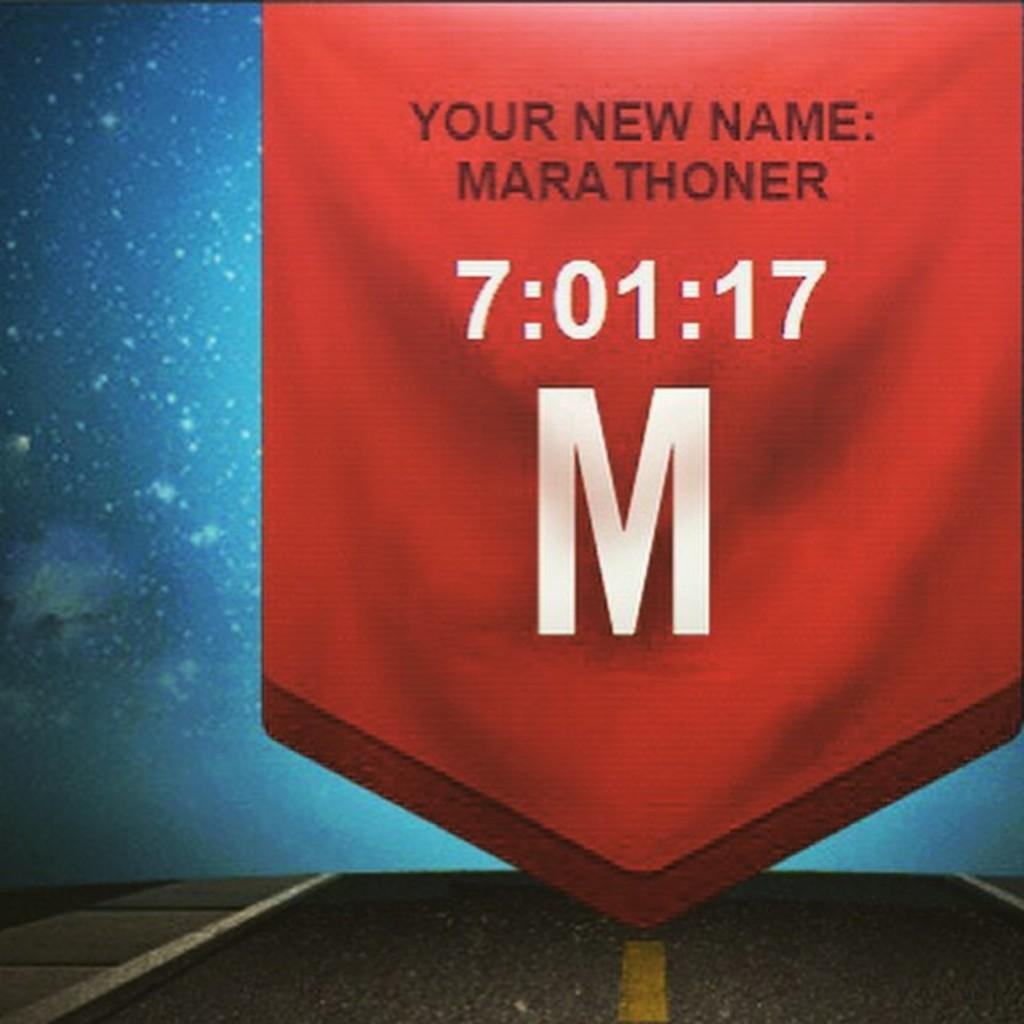<image>
Summarize the visual content of the image. A banner showing a marathoner and its time. 